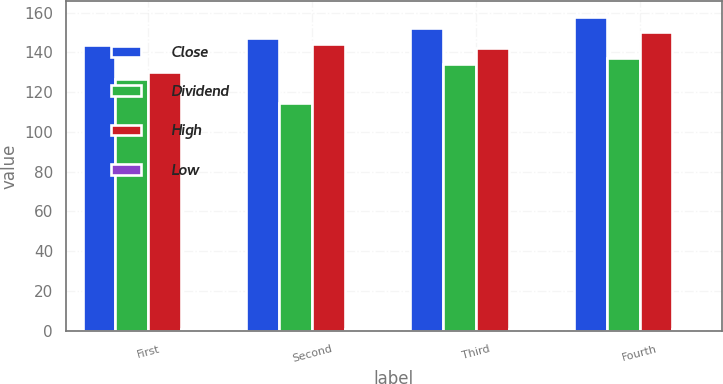Convert chart. <chart><loc_0><loc_0><loc_500><loc_500><stacked_bar_chart><ecel><fcel>First<fcel>Second<fcel>Third<fcel>Fourth<nl><fcel>Close<fcel>143.83<fcel>147.16<fcel>152.16<fcel>157.84<nl><fcel>Dividend<fcel>126.65<fcel>114.64<fcel>134.15<fcel>137.31<nl><fcel>High<fcel>130.11<fcel>144.05<fcel>142.04<fcel>150.34<nl><fcel>Low<fcel>0.81<fcel>0.86<fcel>0.86<fcel>0.86<nl></chart> 